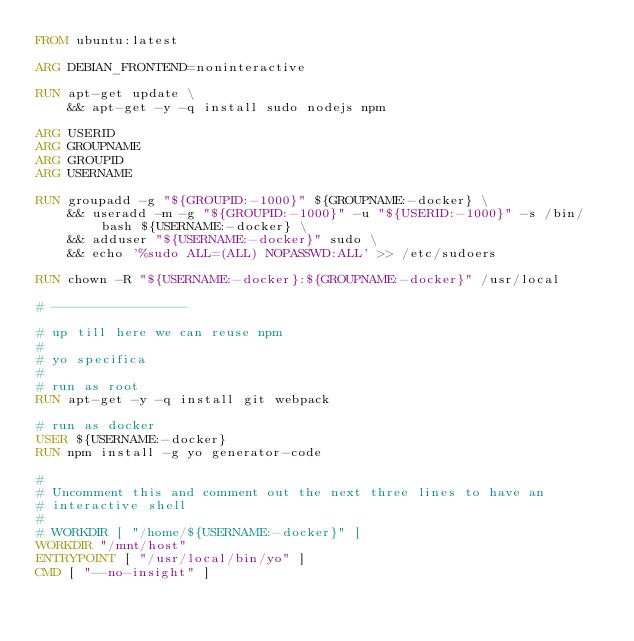<code> <loc_0><loc_0><loc_500><loc_500><_Dockerfile_>FROM ubuntu:latest

ARG DEBIAN_FRONTEND=noninteractive

RUN apt-get update \
    && apt-get -y -q install sudo nodejs npm

ARG USERID
ARG GROUPNAME
ARG GROUPID
ARG USERNAME

RUN groupadd -g "${GROUPID:-1000}" ${GROUPNAME:-docker} \
    && useradd -m -g "${GROUPID:-1000}" -u "${USERID:-1000}" -s /bin/bash ${USERNAME:-docker} \
    && adduser "${USERNAME:-docker}" sudo \
    && echo '%sudo ALL=(ALL) NOPASSWD:ALL' >> /etc/sudoers

RUN chown -R "${USERNAME:-docker}:${GROUPNAME:-docker}" /usr/local

# -----------------

# up till here we can reuse npm
#
# yo specifica
#
# run as root
RUN apt-get -y -q install git webpack

# run as docker
USER ${USERNAME:-docker}
RUN npm install -g yo generator-code

#
# Uncomment this and comment out the next three lines to have an
# interactive shell
#
# WORKDIR [ "/home/${USERNAME:-docker}" ]
WORKDIR "/mnt/host"
ENTRYPOINT [ "/usr/local/bin/yo" ]
CMD [ "--no-insight" ]

</code> 